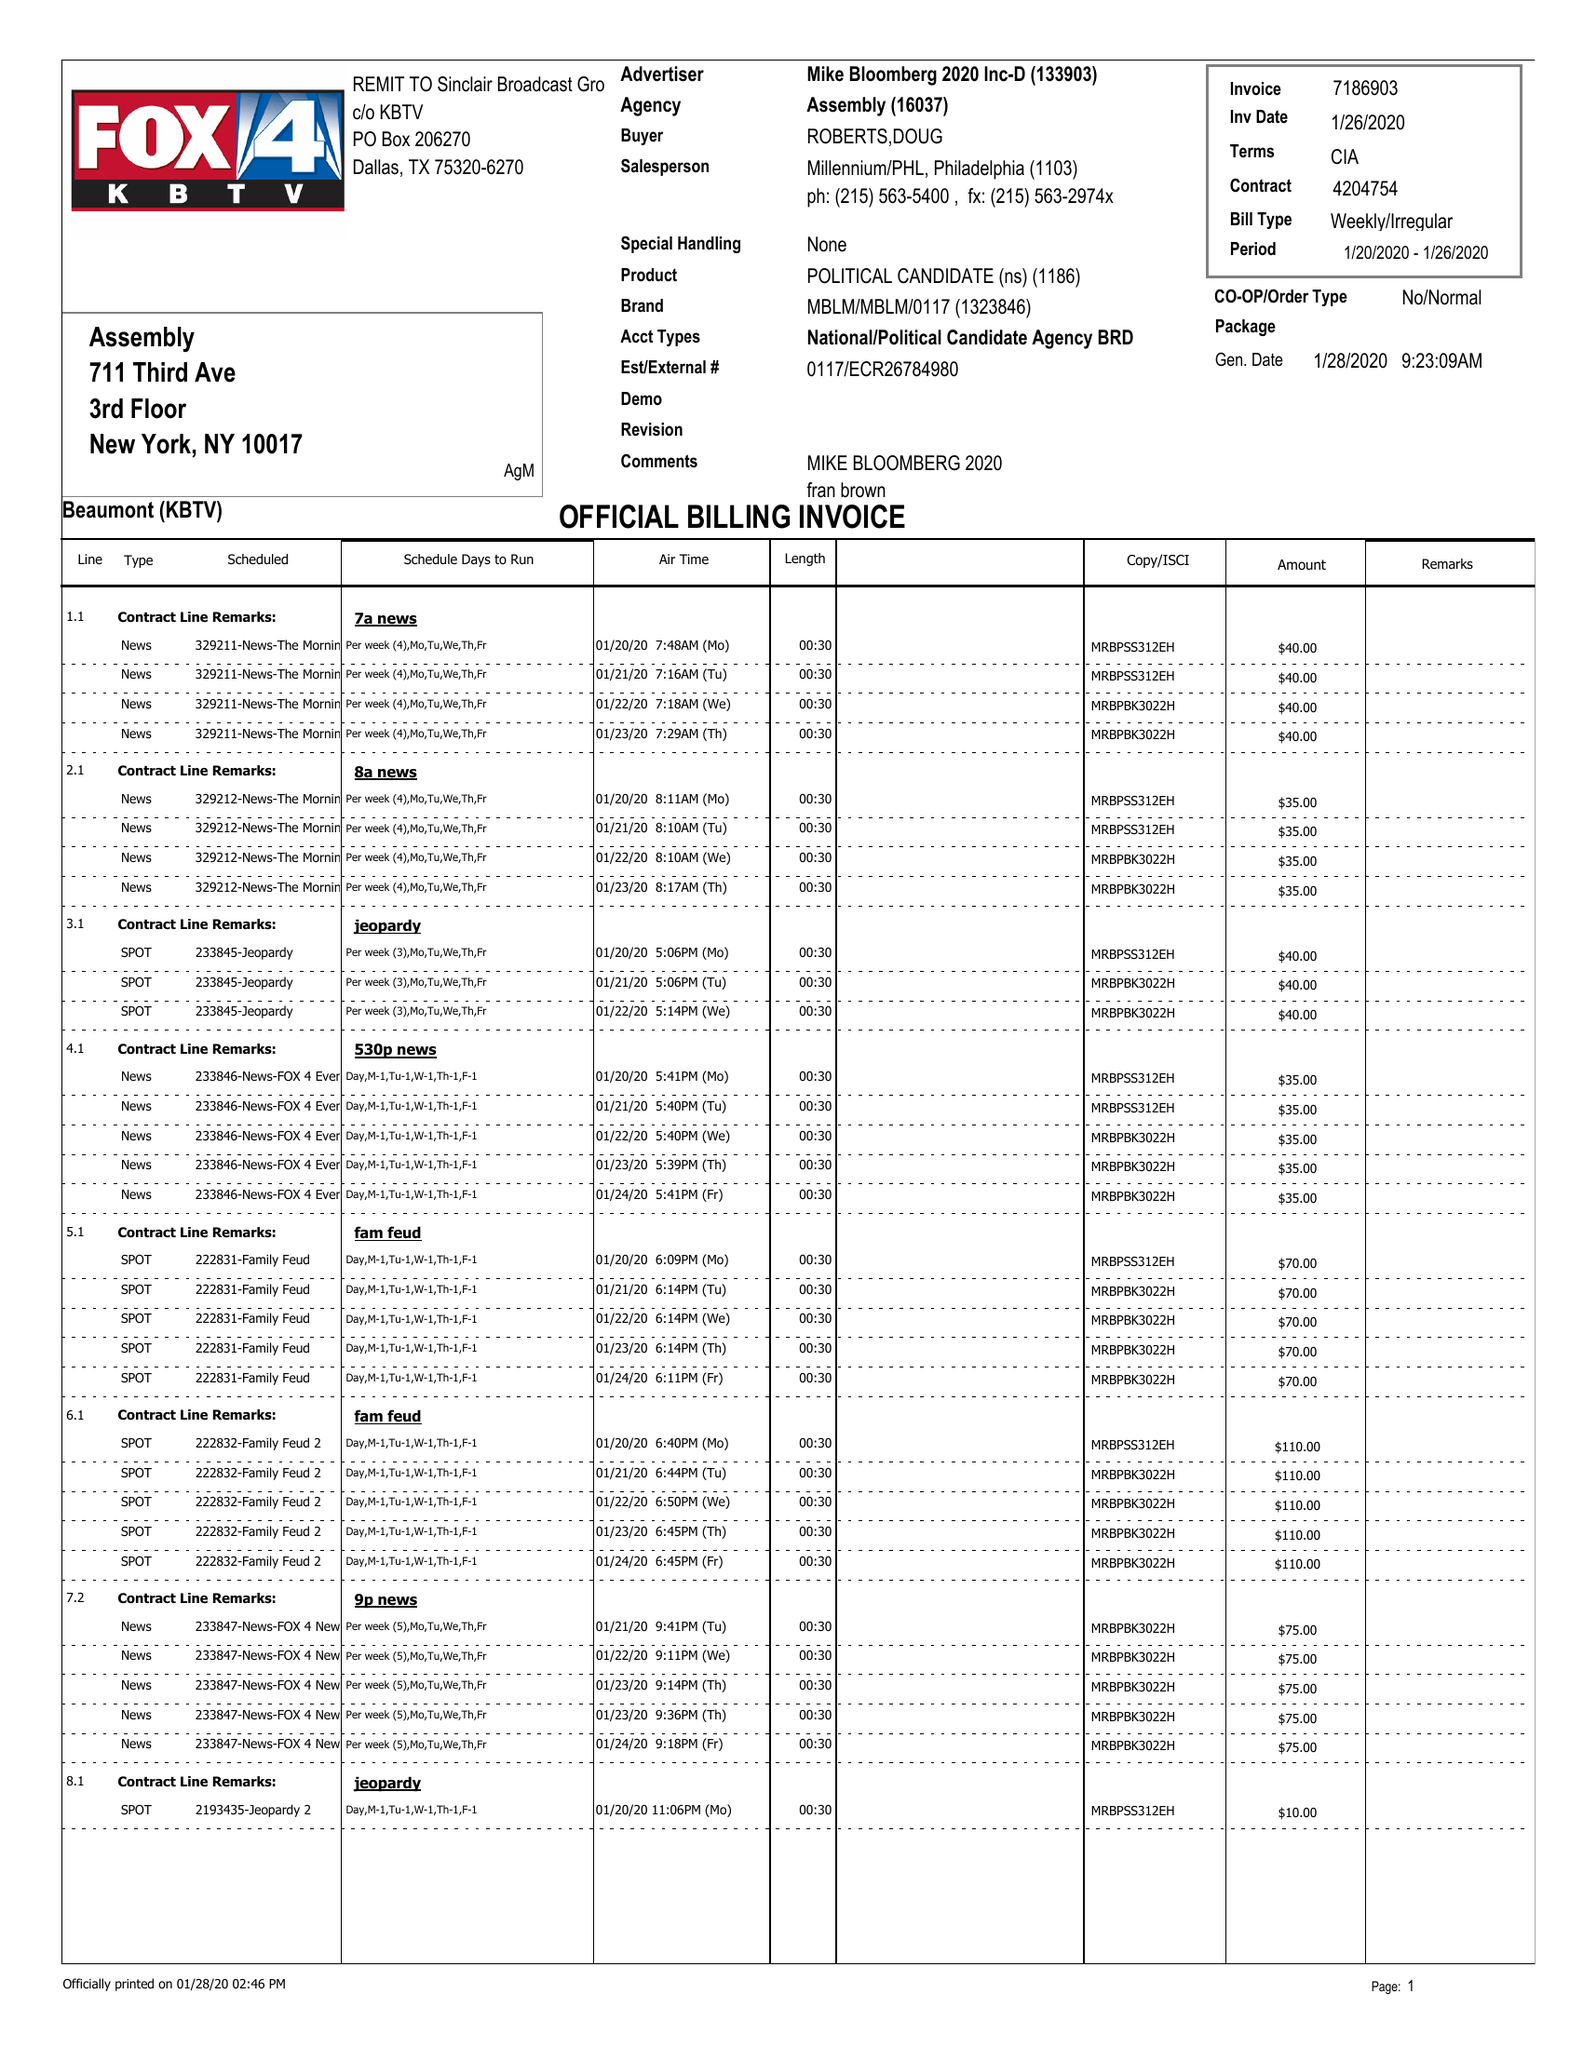What is the value for the flight_from?
Answer the question using a single word or phrase. 01/20/20 